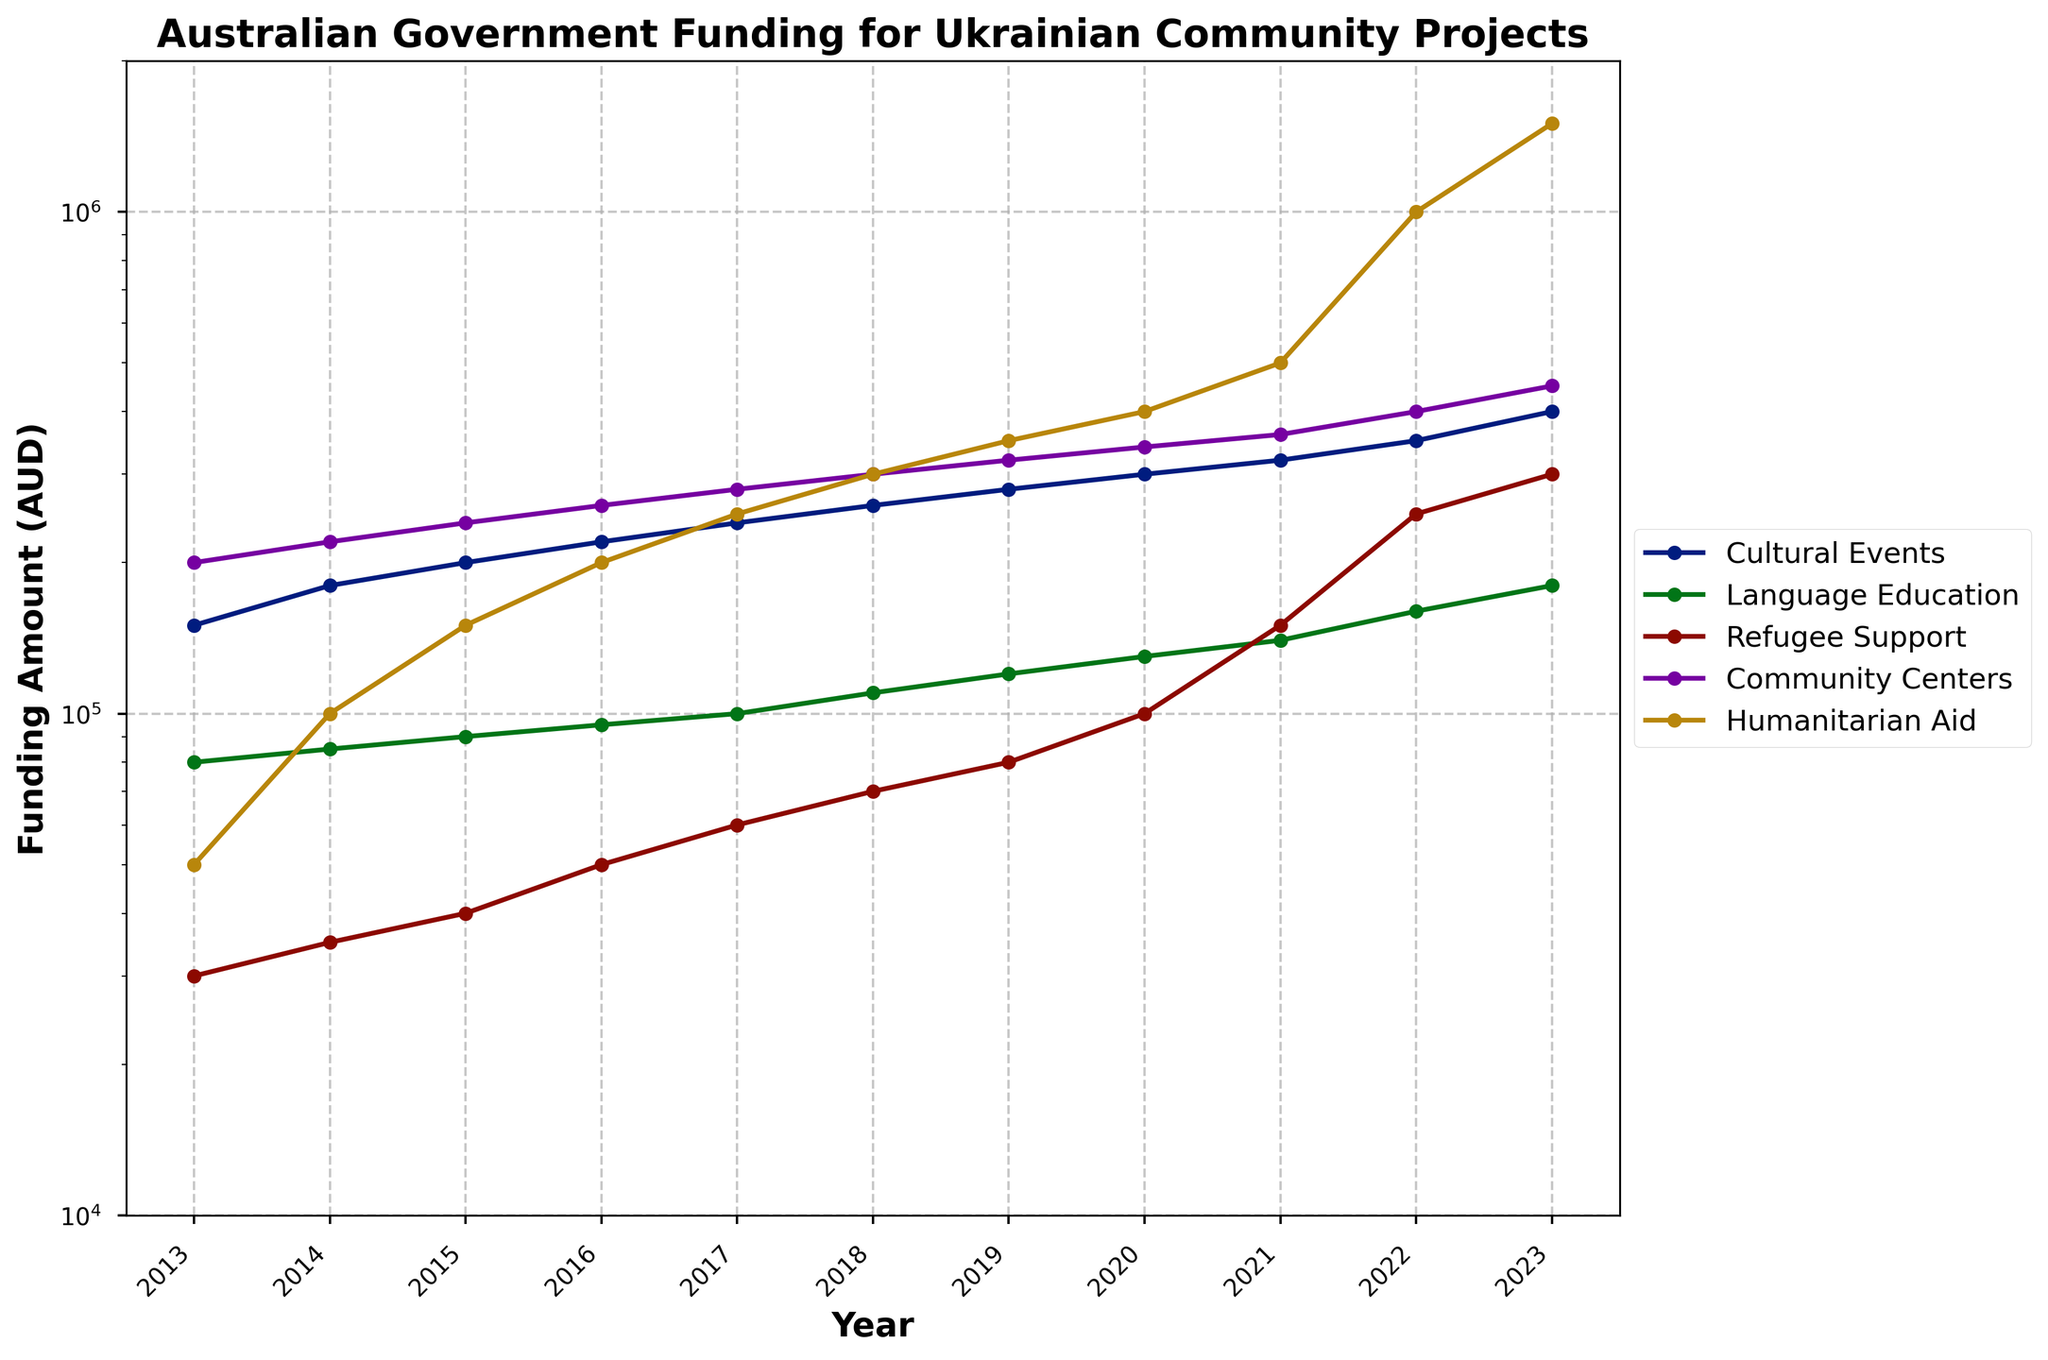What year did funding for Cultural Events first surpass $300,000? Identify the line for Cultural Events, check the points and values associated with each year, and note when it first exceeds $300,000.
Answer: 2020 Between Language Education and Community Centers, which initiative had more consistent growth over time? Look at the trajectories for Language Education and Community Centers and see which line has a smoother, more regular increase.
Answer: Language Education What’s the total funding for Humanitarian Aid in 2023 and 2022 combined? Locate the points for Humanitarian Aid for years 2023 and 2022. Add the two values: 1,500,000 (2023) + 1,000,000 (2022).
Answer: 2,500,000 In which year did Refugee Support funding see its largest increase from the previous year? Compare the differences in Refugee Support funding between consecutive years, identify the year with the largest increase.
Answer: 2021 By how much did funding for Community Centers increase from 2013 to 2023? Subtract the Community Centers funding in 2013 from the funding in 2023: 450,000 (2023) - 200,000 (2013).
Answer: 250,000 Which initiative received the highest funding in 2023? Identify the highest point in 2023 among all initiative lines.
Answer: Humanitarian Aid In what year did Humanitarian Aid funding exceed $500,000? Follow the Humanitarian Aid line and find the year it first goes above $500,000.
Answer: 2021 How does the growth rate of Refugee Support funding between 2020 and 2022 compare to that of Cultural Events? Calculate the increase for Refugee Support: 250,000 - 100,000 (2022-2020). Calculate for Cultural Events: 350,000 - 300,000 (2022-2020). Compare the increases.
Answer: Refugee Support grew faster than Cultural Events What was the average funding for Language Education from 2013 to 2023? Sum the values for Language Education for each year from 2013 to 2023 and divide by the number of years: (80,000 + 85,000 + 90,000 + 95,000 + 100,000 + 110,000 + 120,000 + 130,000 + 140,000 + 160,000 + 180,000) / 11.
Answer: 118,182 